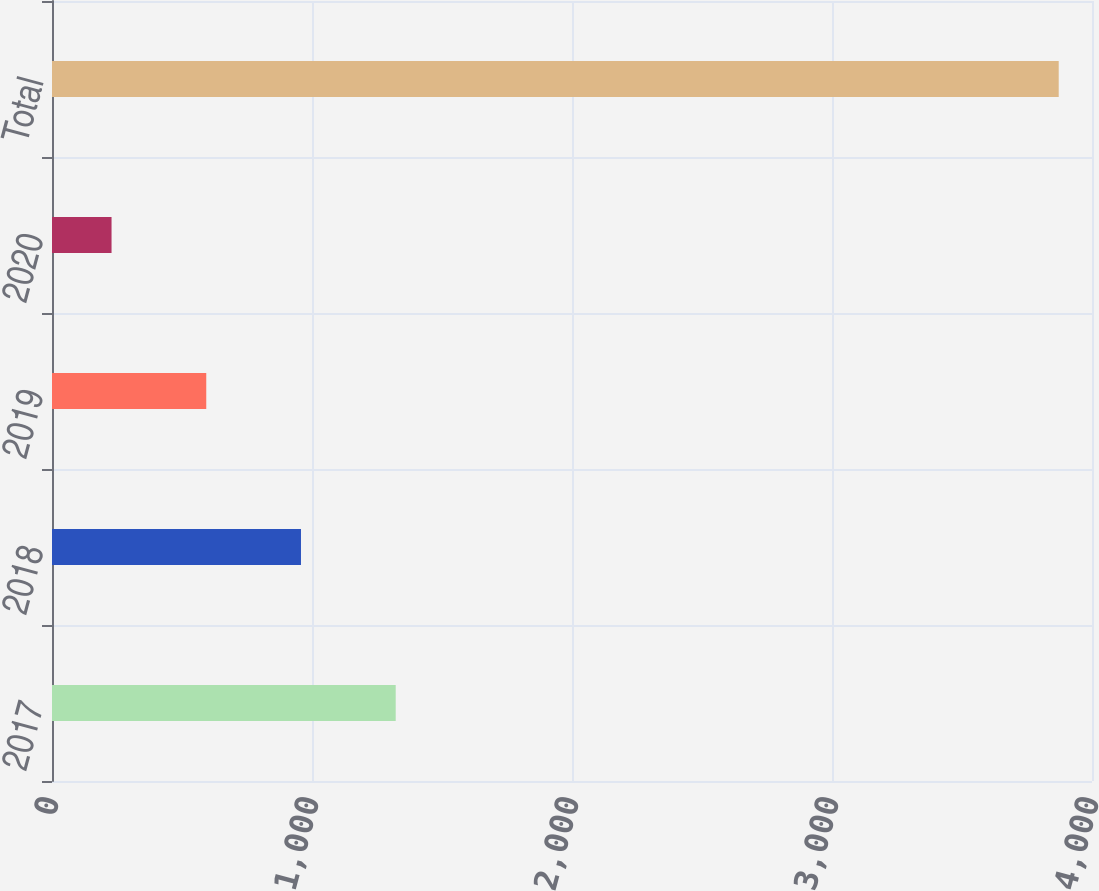<chart> <loc_0><loc_0><loc_500><loc_500><bar_chart><fcel>2017<fcel>2018<fcel>2019<fcel>2020<fcel>Total<nl><fcel>1321.9<fcel>957.6<fcel>593.3<fcel>229<fcel>3872<nl></chart> 